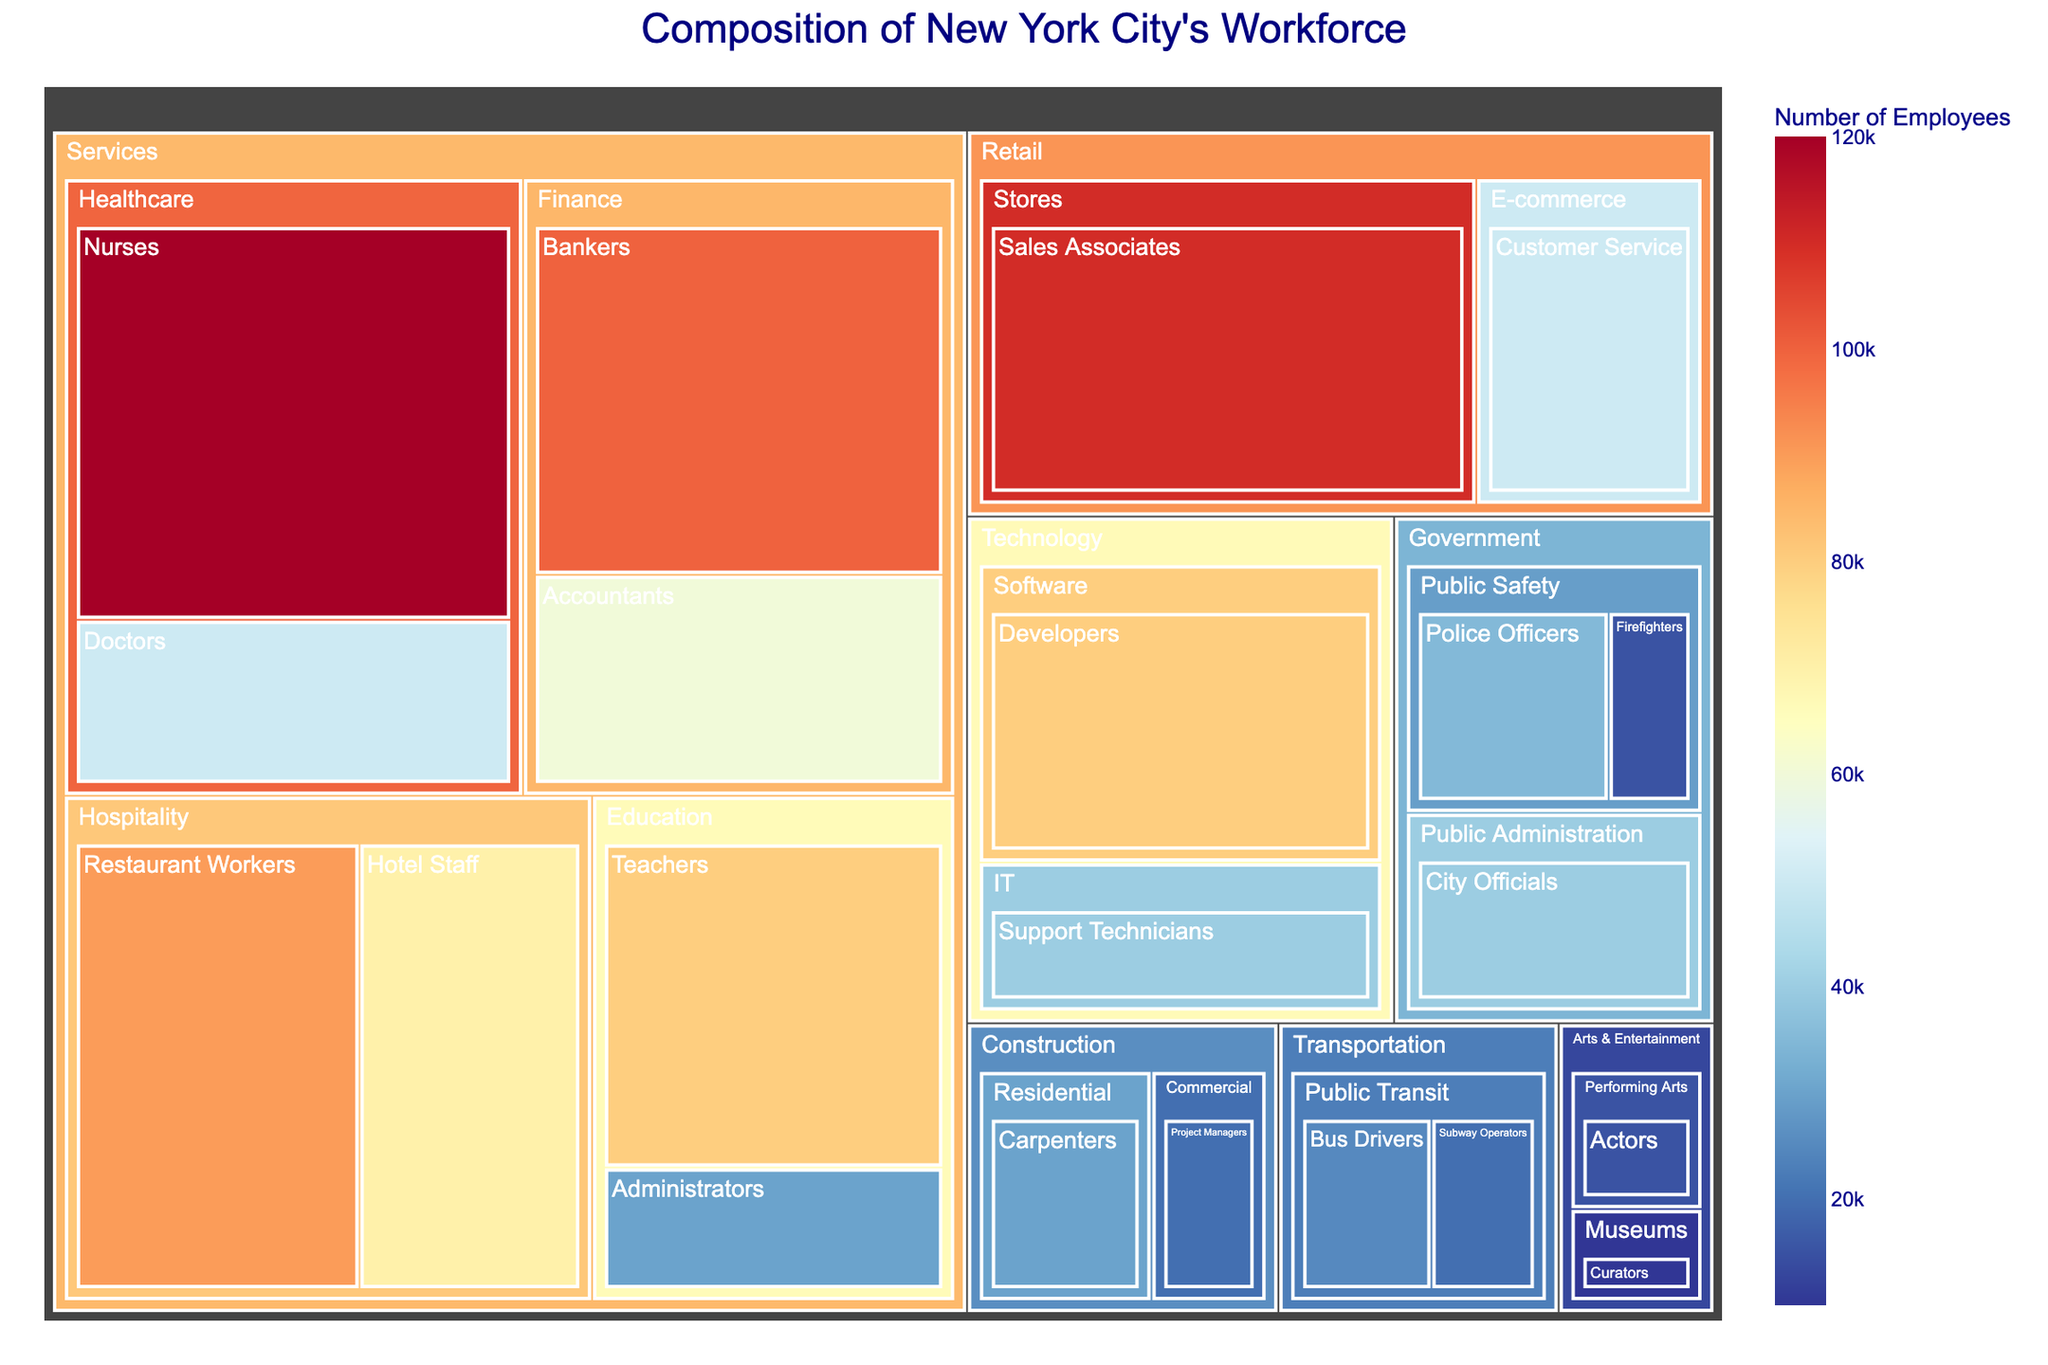What is the title of the figure? The title is typically placed at the top of the figure in a larger, bold font. In this case, the title "Composition of New York City's Workforce" is clearly visible at the center top.
Answer: Composition of New York City's Workforce Which job type has the largest number of employees? The treemap visualizes job types with different sizes proportional to the number of employees. The largest section of the treemap represents "Nurses" in the "Healthcare" sector under "Services" with 120,000 employees.
Answer: Nurses How many people are employed in the Government sector? Identify all job types under the Government sector in the treemap: City Officials, Police Officers, and Firefighters. Add their employee counts: 40,000 (City Officials) + 35,000 (Police Officers) + 15,000 (Firefighters). Therefore, it's 90,000.
Answer: 90,000 Which sector has more employees: Technology or Arts & Entertainment? Compare the sum of employees in the Technology sector (Developers: 80,000 and Support Technicians: 40,000) and Arts & Entertainment sector (Actors: 15,000 and Curators: 10,000). Technology has 120,000 employees, and Arts & Entertainment has 25,000 employees.
Answer: Technology What is the smallest job type in terms of employees? Look for the smallest section in the treemap. "Curators" in the "Museums" sector under "Arts & Entertainment" is the smallest with 10,000 employees.
Answer: Curators How many job types are there in the Services industry? Count the distinct job types under the Services industry: Nurses, Doctors, Teachers, Administrators, Bankers, Accountants, Hotel Staff, Restaurant Workers. There are 8 job types in total.
Answer: 8 Which sector within Services has the highest number of employees? Calculate the total number of employees for each sector within Services: Healthcare (Nurses: 120,000 + Doctors: 50,000), Education (Teachers: 80,000 + Administrators: 30,000), Finance (Bankers: 100,000 + Accountants: 60,000), Hospitality (Hotel Staff: 70,000 + Restaurant Workers: 90,000). The highest is Healthcare with 170,000 employees.
Answer: Healthcare Add the number of employees in the Retail and Transportation industries. Sum the employees from the Retail industry (Sales Associates: 110,000 + Customer Service: 50,000) and the Transportation industry (Bus Drivers: 25,000 + Subway Operators: 20,000). Therefore, 160,000 (Retail) + 45,000 (Transportation) = 205,000.
Answer: 205,000 Which job type in the public sector has fewer employees, Police Officers or City Officials? Examine the employee counts for both job types: Police Officers have 35,000 employees and City Officials have 40,000 employees. Police Officers have fewer employees.
Answer: Police Officers 